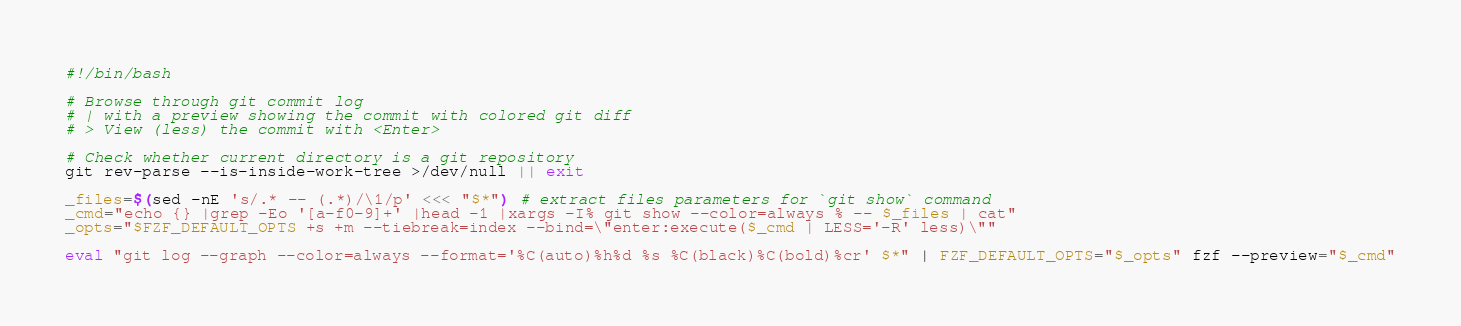Convert code to text. <code><loc_0><loc_0><loc_500><loc_500><_Bash_>#!/bin/bash

# Browse through git commit log
# | with a preview showing the commit with colored git diff
# > View (less) the commit with <Enter>

# Check whether current directory is a git repository
git rev-parse --is-inside-work-tree >/dev/null || exit

_files=$(sed -nE 's/.* -- (.*)/\1/p' <<< "$*") # extract files parameters for `git show` command
_cmd="echo {} |grep -Eo '[a-f0-9]+' |head -1 |xargs -I% git show --color=always % -- $_files | cat"
_opts="$FZF_DEFAULT_OPTS +s +m --tiebreak=index --bind=\"enter:execute($_cmd | LESS='-R' less)\""

eval "git log --graph --color=always --format='%C(auto)%h%d %s %C(black)%C(bold)%cr' $*" | FZF_DEFAULT_OPTS="$_opts" fzf --preview="$_cmd"
</code> 